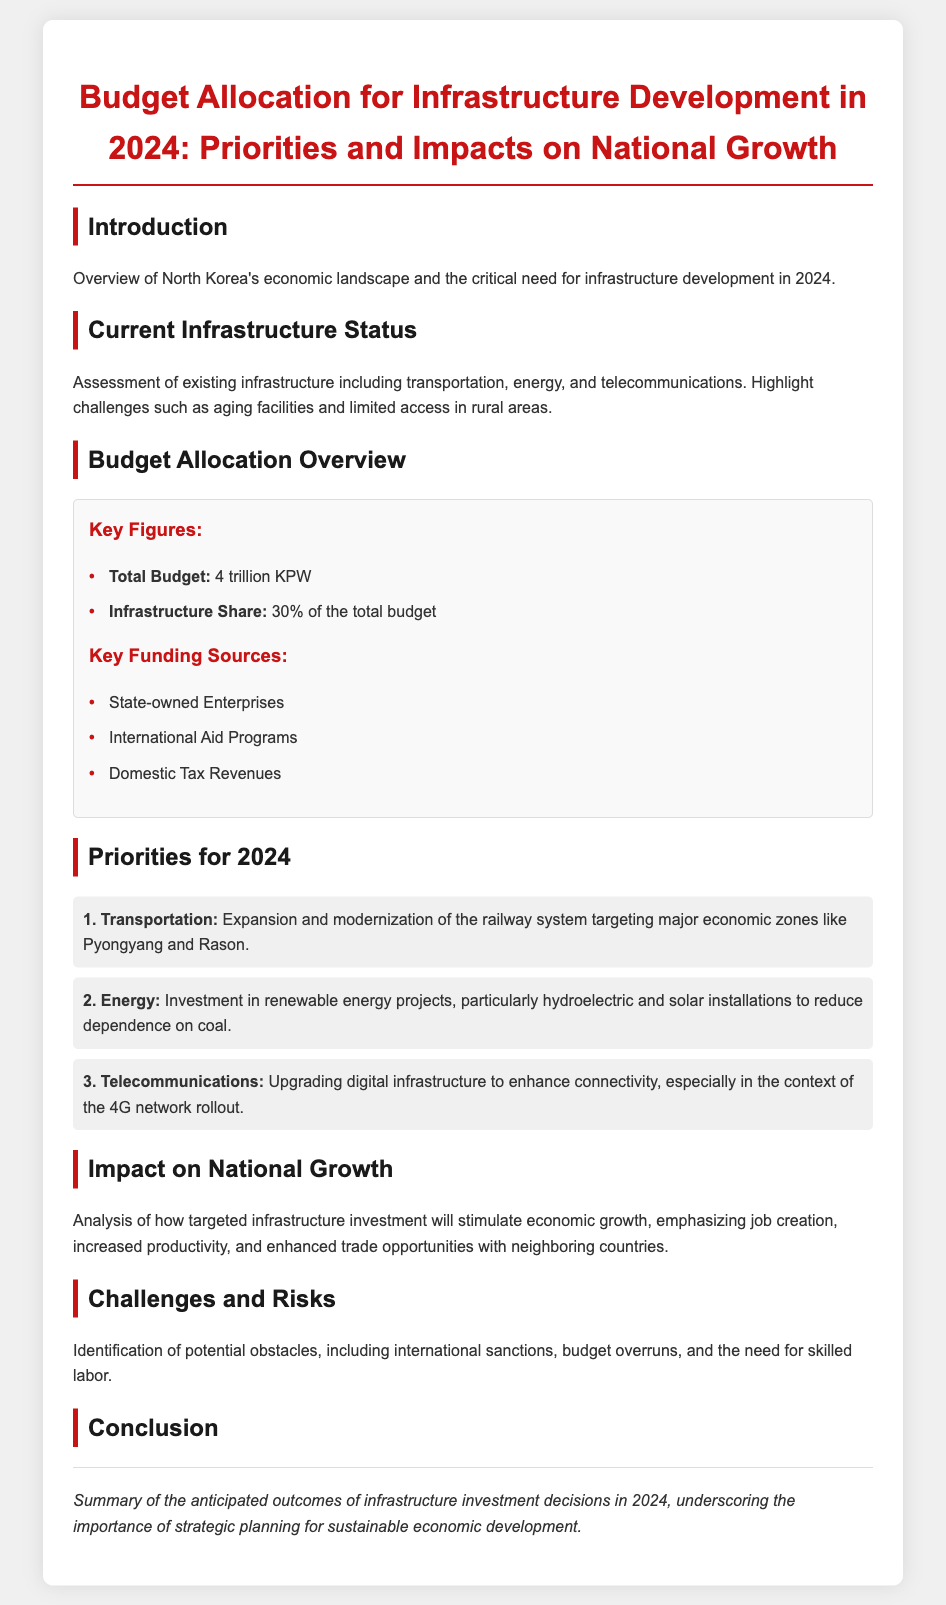What is the total budget for 2024? The total budget is explicitly stated in the document as 4 trillion KPW.
Answer: 4 trillion KPW What percentage of the total budget is allocated for infrastructure? The document specifies that the infrastructure share is 30% of the total budget.
Answer: 30% Which economic zones are targeted for transportation investments? The document mentions major economic zones like Pyongyang and Rason for the transportation expansion.
Answer: Pyongyang and Rason What are the key funding sources for the infrastructure budget? The document lists three key funding sources, including State-owned Enterprises, International Aid Programs, and Domestic Tax Revenues.
Answer: State-owned Enterprises, International Aid Programs, Domestic Tax Revenues What is the first priority area for the budget allocation in 2024? The document identifies Transportation as the first priority in the budget allocation.
Answer: Transportation How will targeted infrastructure investment impact national growth? The analysis in the document emphasizes job creation, increased productivity, and enhanced trade opportunities as impacts of targeted infrastructure investment.
Answer: Job creation, increased productivity, enhanced trade opportunities What challenges are identified in the document for infrastructure development? The document states potential obstacles including international sanctions, budget overruns, and the need for skilled labor.
Answer: International sanctions, budget overruns, need for skilled labor What is the anticipated outcome of infrastructure investment decisions in 2024? The conclusion in the document underscores the importance of strategic planning for sustainable economic development as the anticipated outcome.
Answer: Strategic planning for sustainable economic development 